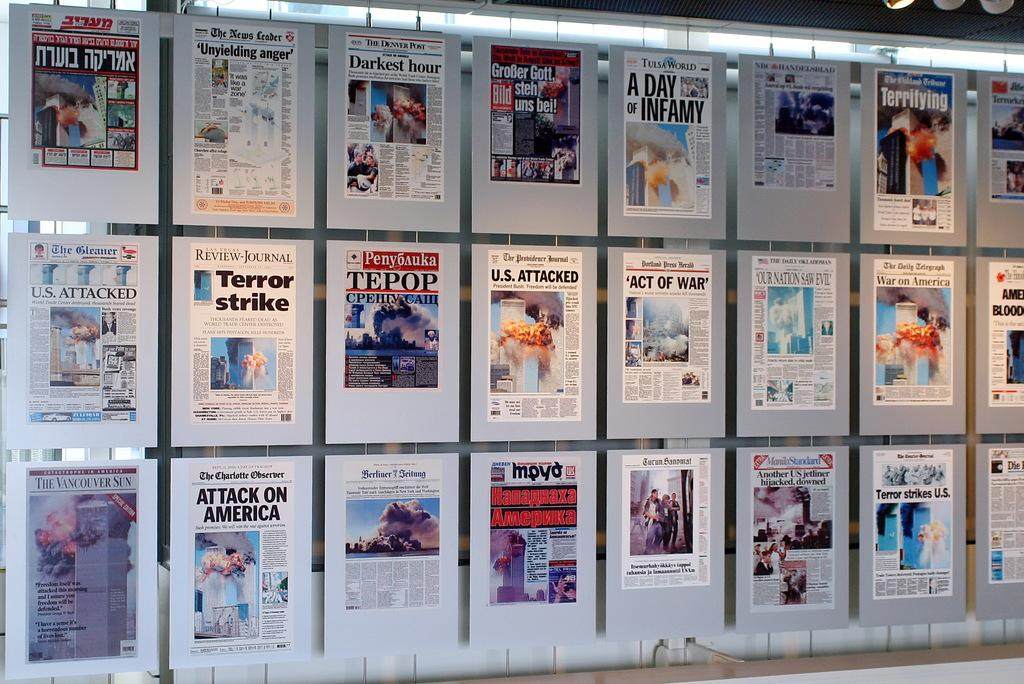<image>
Summarize the visual content of the image. Billboard showing different news on america and the U.S being attacked 